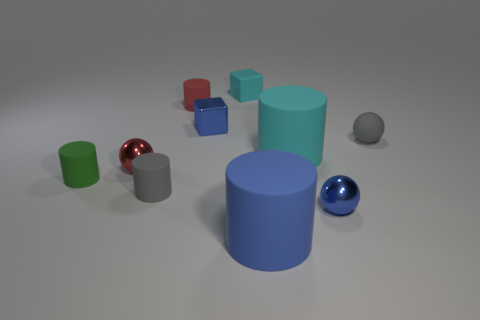Subtract all large cylinders. How many cylinders are left? 3 Subtract all red spheres. How many spheres are left? 2 Subtract all blocks. How many objects are left? 8 Subtract 3 spheres. How many spheres are left? 0 Subtract all yellow spheres. Subtract all brown blocks. How many spheres are left? 3 Subtract all purple cylinders. How many cyan cubes are left? 1 Subtract all gray things. Subtract all large cyan rubber cylinders. How many objects are left? 7 Add 1 small red rubber cylinders. How many small red rubber cylinders are left? 2 Add 7 green rubber cylinders. How many green rubber cylinders exist? 8 Subtract 0 yellow cubes. How many objects are left? 10 